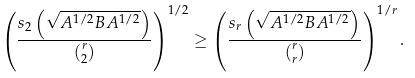Convert formula to latex. <formula><loc_0><loc_0><loc_500><loc_500>\left ( \frac { s _ { 2 } \left ( \sqrt { A ^ { 1 / 2 } B A ^ { 1 / 2 } } \right ) } { \binom { r } { 2 } } \right ) ^ { 1 / 2 } \geq \left ( \frac { s _ { r } \left ( \sqrt { A ^ { 1 / 2 } B A ^ { 1 / 2 } } \right ) } { \binom { r } { r } } \right ) ^ { 1 / r } .</formula> 